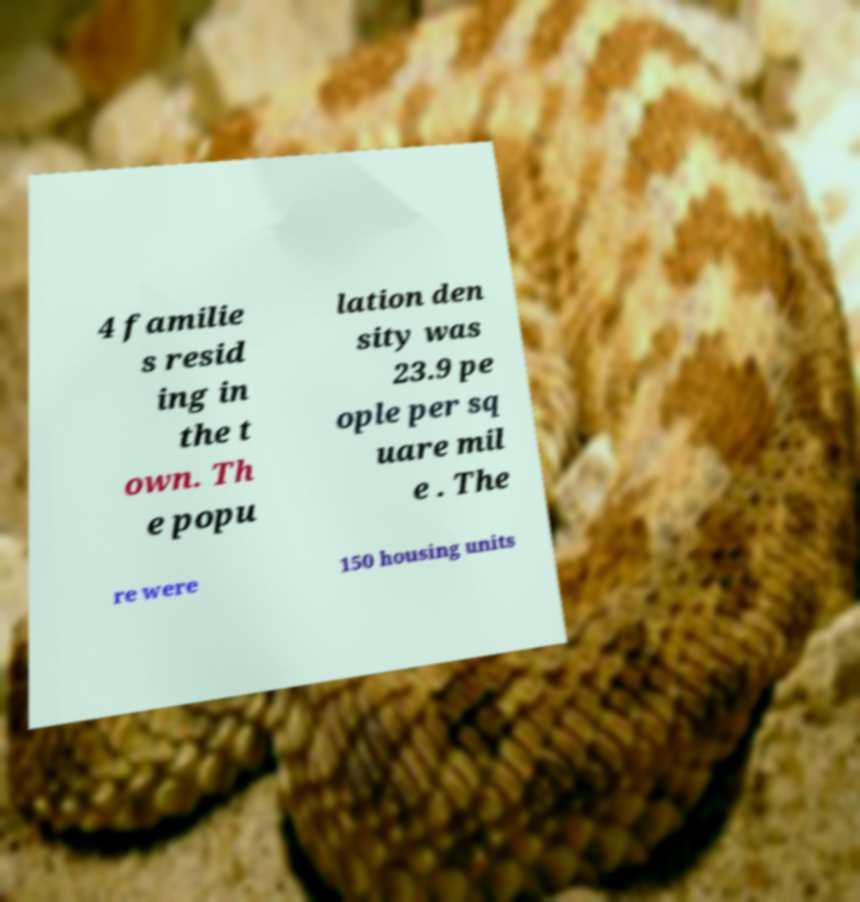What messages or text are displayed in this image? I need them in a readable, typed format. 4 familie s resid ing in the t own. Th e popu lation den sity was 23.9 pe ople per sq uare mil e . The re were 150 housing units 